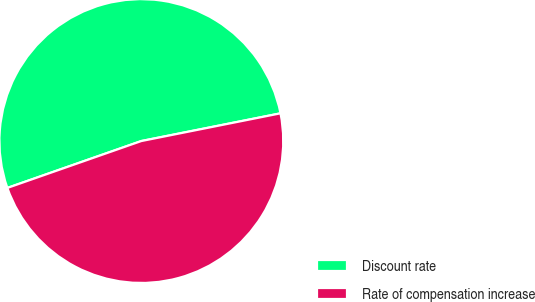Convert chart to OTSL. <chart><loc_0><loc_0><loc_500><loc_500><pie_chart><fcel>Discount rate<fcel>Rate of compensation increase<nl><fcel>52.23%<fcel>47.77%<nl></chart> 